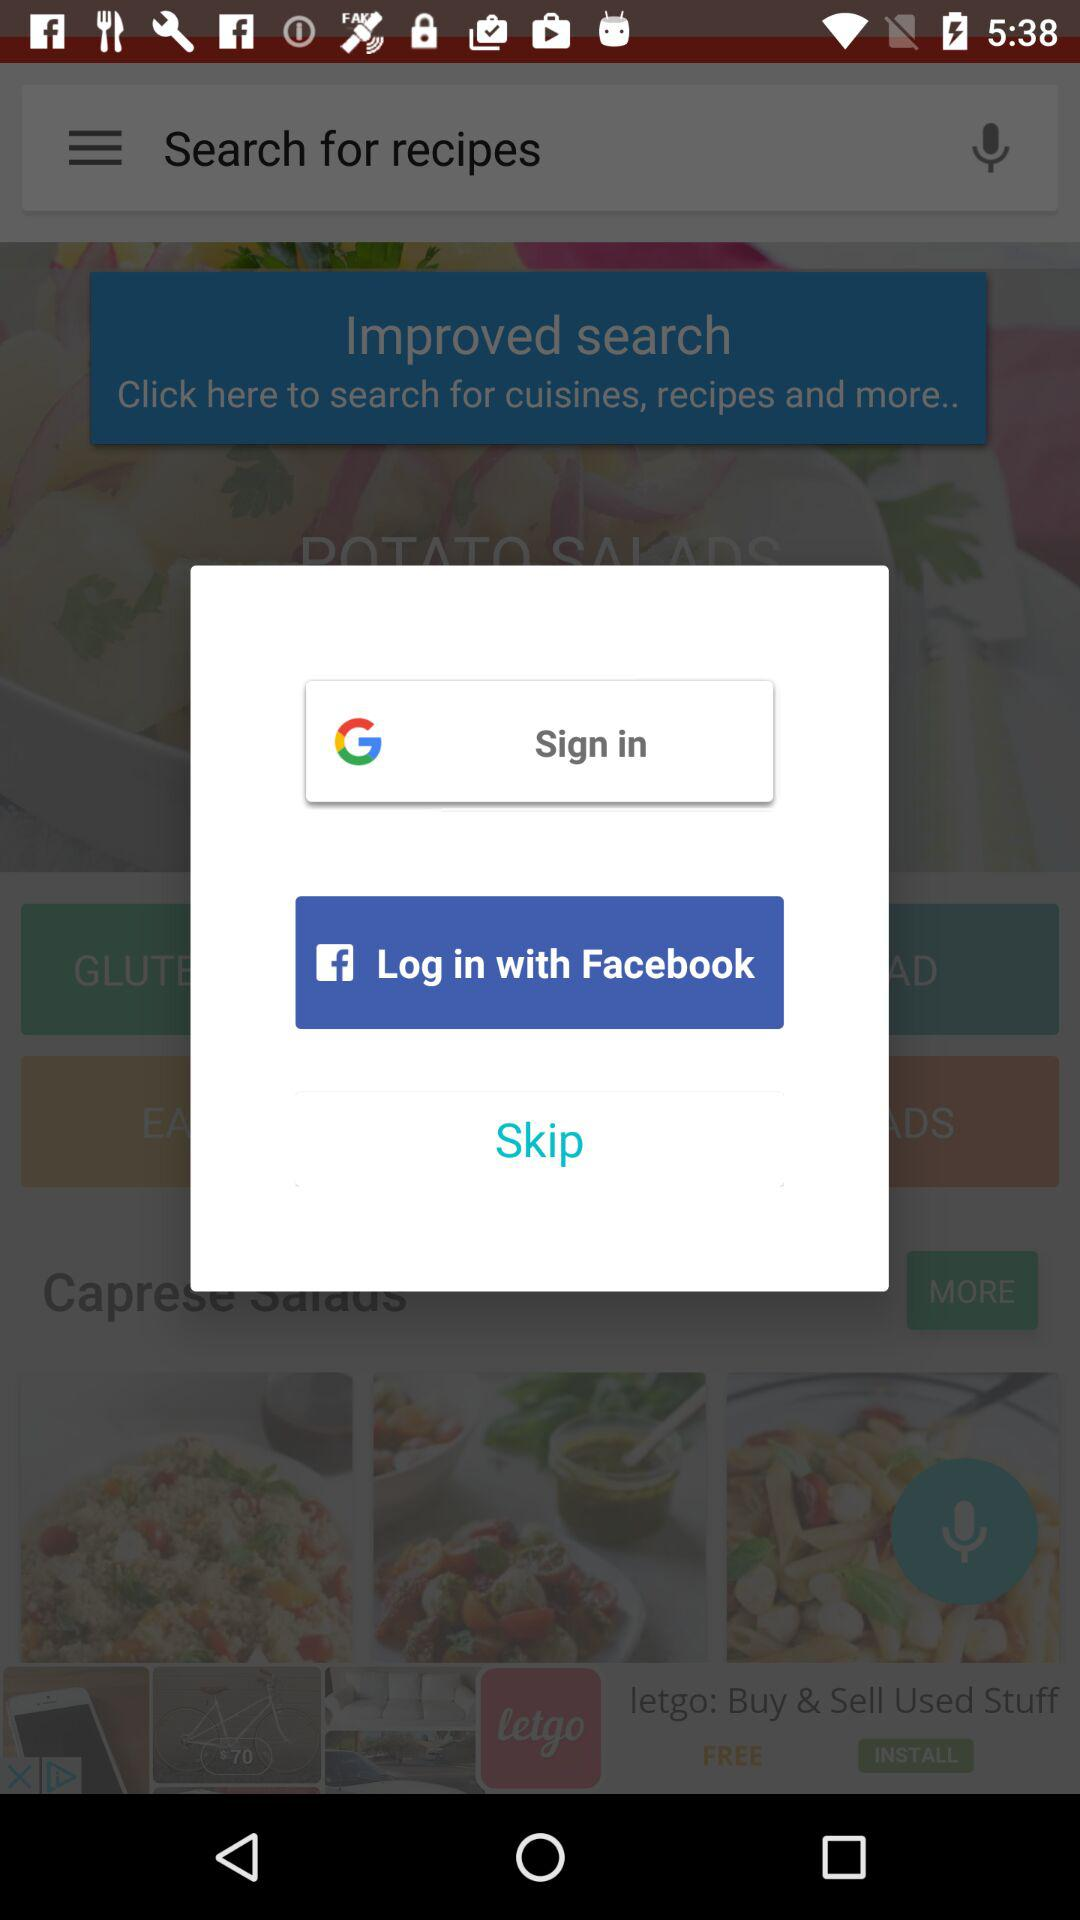Which accounts can be used to sign in? The accounts that can be used to sign in are "Google" and "Facebook". 